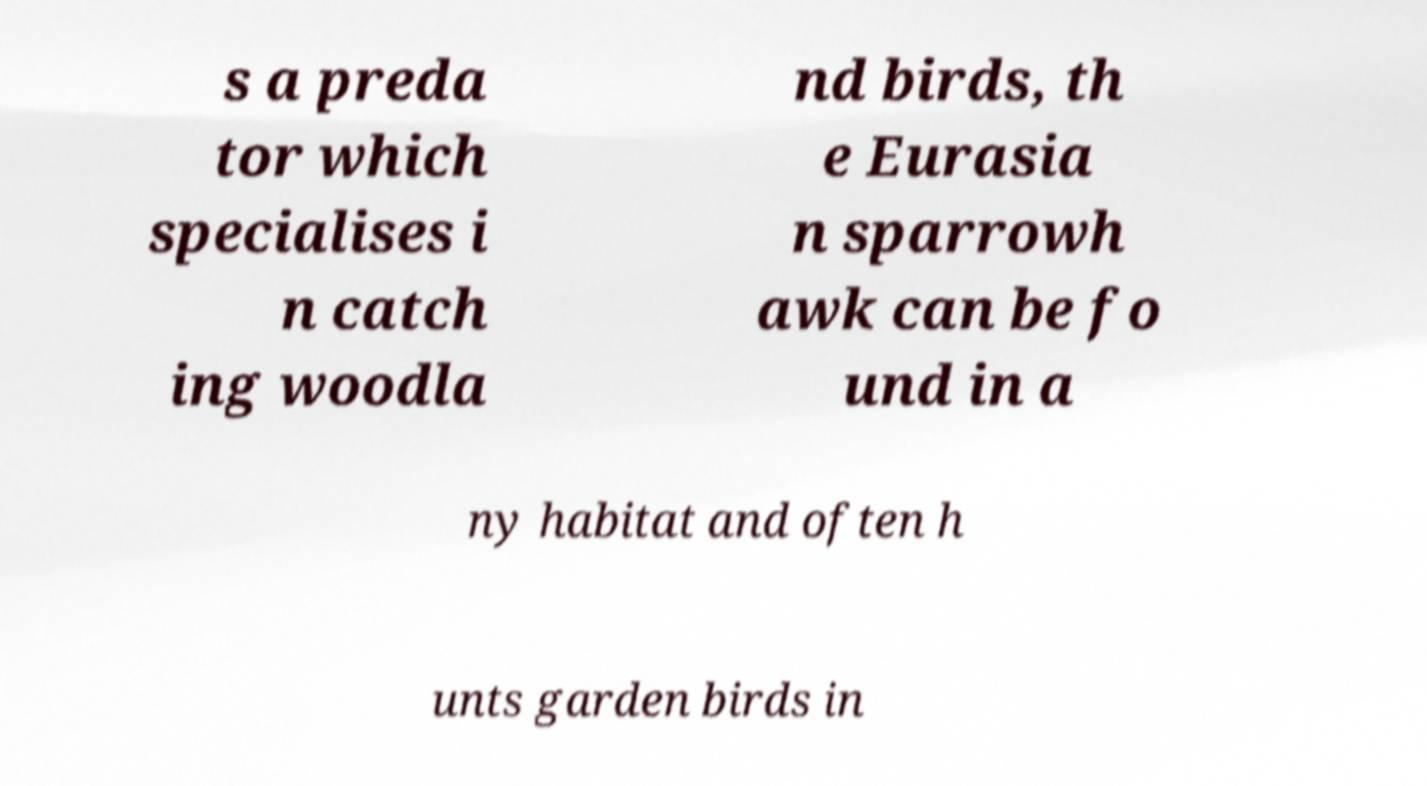Could you extract and type out the text from this image? s a preda tor which specialises i n catch ing woodla nd birds, th e Eurasia n sparrowh awk can be fo und in a ny habitat and often h unts garden birds in 